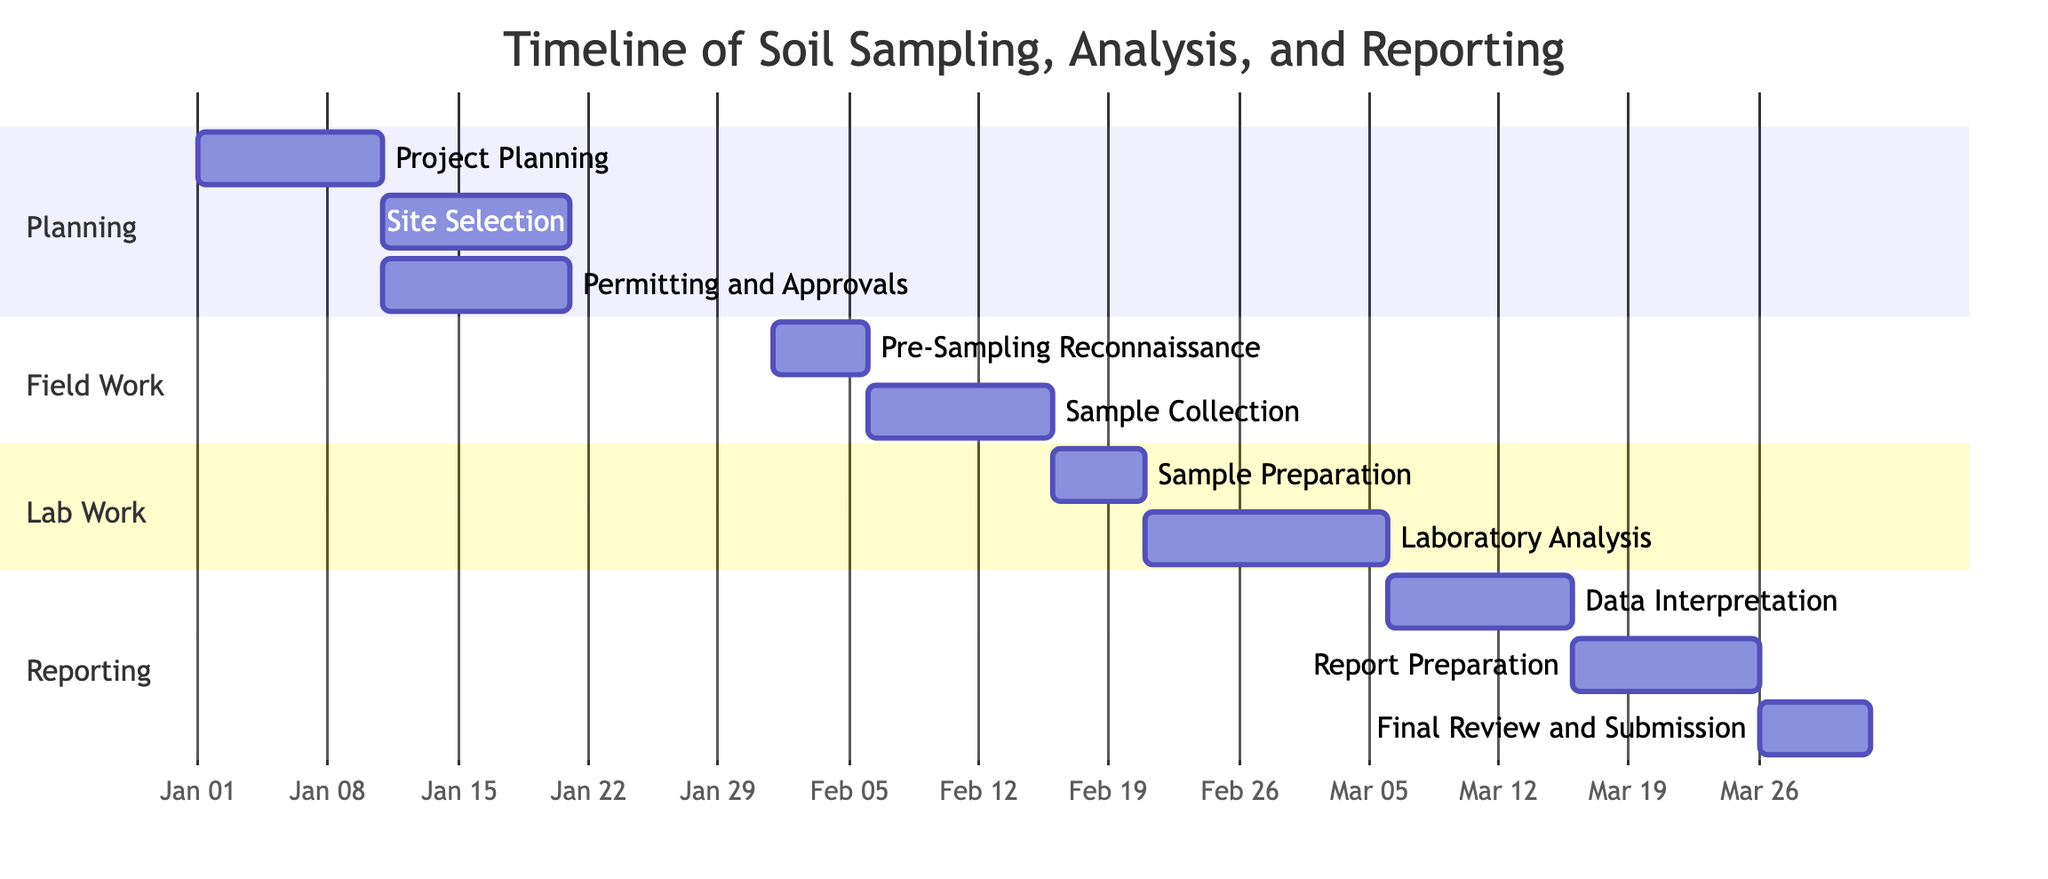what is the duration of the "Sample Collection" phase? The "Sample Collection" phase starts on February 6, 2023, and ends on February 15, 2023. To find the duration, you count the days between these two dates, which is exactly 10 days.
Answer: 10 days which task immediately follows "Sample Preparation"? The task that immediately follows "Sample Preparation" is "Laboratory Analysis". In the Gantt chart, "Laboratory Analysis" is scheduled to start after the completion of "Sample Preparation".
Answer: Laboratory Analysis how many tasks are there in the "Field Work" section? The "Field Work" section contains two tasks: "Pre-Sampling Reconnaissance" and "Sample Collection". You can count the individual tasks listed within that section of the Gantt chart to arrive at the total.
Answer: 2 what is the total number of tasks in the Gantt chart? The Gantt chart consists of a total of 10 tasks. By counting each task listed in the four sections of the Gantt chart (Planning, Field Work, Lab Work, and Reporting), you can determine that there are 10 distinct tasks.
Answer: 10 which task has the longest duration and how long is it? The task with the longest duration is "Laboratory Analysis", which lasts from February 21, 2023, to March 5, 2023, resulting in a duration of 13 days. By calculating the number of days between these start and end dates, the longest duration is identified.
Answer: 13 days when does the "Final Review and Submission" begin? The "Final Review and Submission" task begins on March 26, 2023. It is the final task in the Gantt chart, and you can find its start date by looking at its timeline in the last section of the diagram.
Answer: March 26, 2023 which two tasks are dependent on "Project Planning"? The two tasks that depend on "Project Planning" are "Site Selection" and "Permitting and Approvals". You can identify these dependencies from the arrows that illustrate the relationships in the Gantt chart.
Answer: Site Selection and Permitting and Approvals how many days apart are the start of "Data Interpretation" and the end of "Laboratory Analysis"? "Data Interpretation" starts on March 6, 2023, and "Laboratory Analysis" ends on March 5, 2023. The gap between these two dates is 1 day, so "Data Interpretation" starts one day after "Laboratory Analysis" ends.
Answer: 1 day 